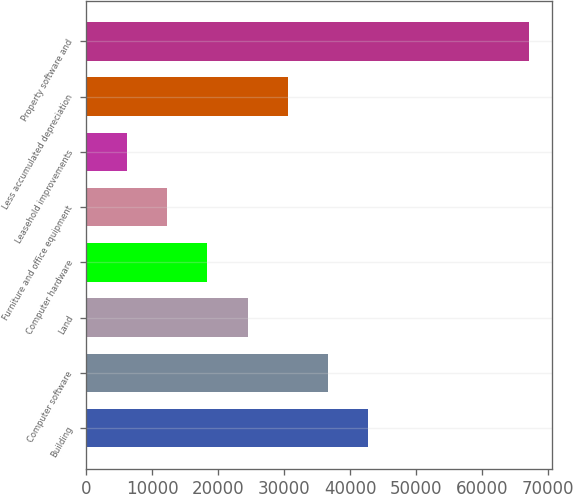Convert chart to OTSL. <chart><loc_0><loc_0><loc_500><loc_500><bar_chart><fcel>Building<fcel>Computer software<fcel>Land<fcel>Computer hardware<fcel>Furniture and office equipment<fcel>Leasehold improvements<fcel>Less accumulated depreciation<fcel>Property software and<nl><fcel>42769.4<fcel>36662<fcel>24447.2<fcel>18339.8<fcel>12232.4<fcel>6125<fcel>30554.6<fcel>67199<nl></chart> 